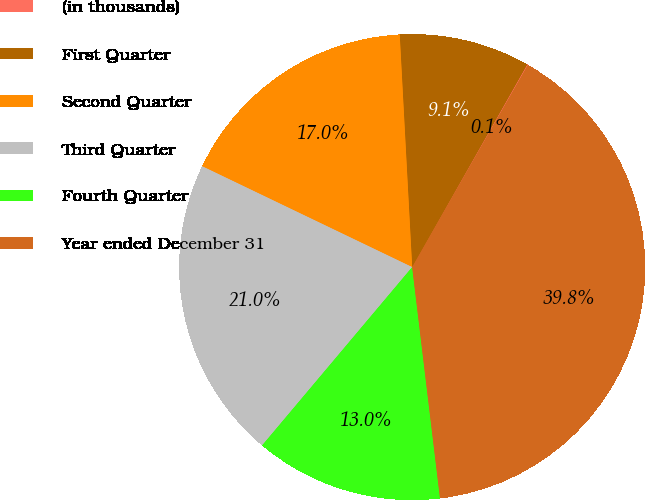Convert chart. <chart><loc_0><loc_0><loc_500><loc_500><pie_chart><fcel>(in thousands)<fcel>First Quarter<fcel>Second Quarter<fcel>Third Quarter<fcel>Fourth Quarter<fcel>Year ended December 31<nl><fcel>0.06%<fcel>9.07%<fcel>17.02%<fcel>20.99%<fcel>13.04%<fcel>39.81%<nl></chart> 